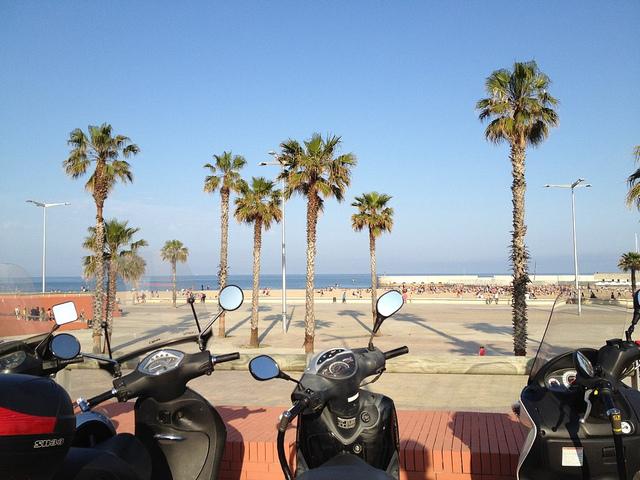Is this a picture of the beach?
Give a very brief answer. Yes. Why are the motorcycles parked here?
Give a very brief answer. Parking area for beach. How many scooters are there in this picture?
Short answer required. 4. How many trees can you see?
Answer briefly. 10. 